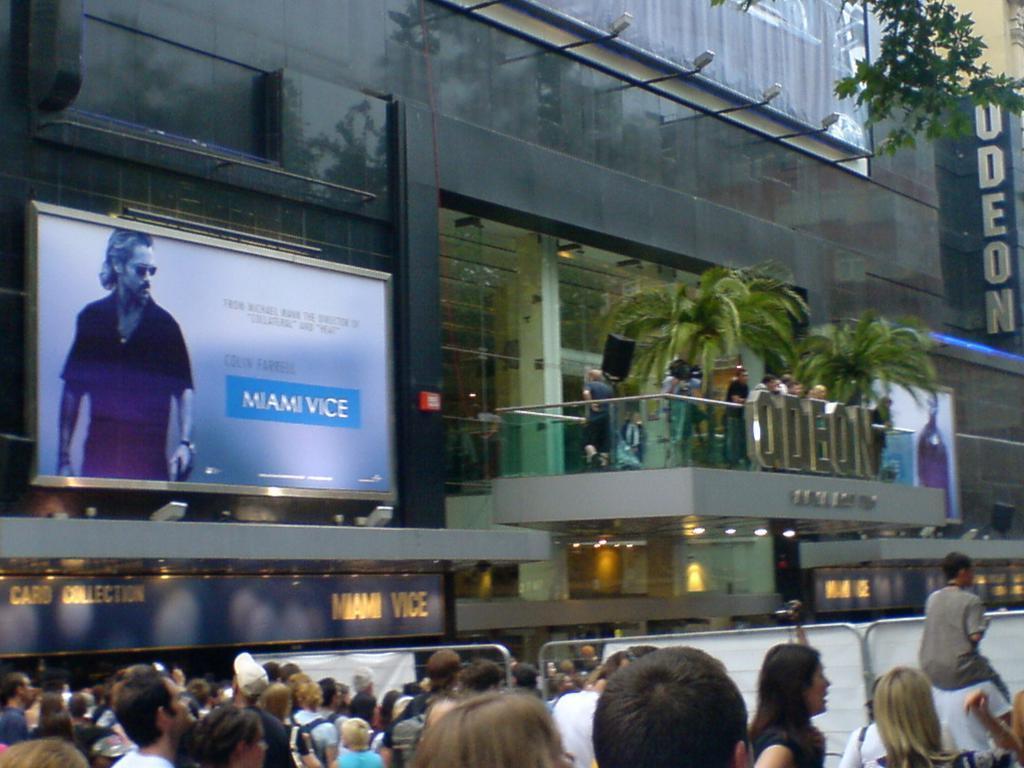Describe this image in one or two sentences. At the bottom of the picture, we see the people are standing. In front of them, we see the steel barriers and the banners in white color. On the left side, we see a hoarding board of a man. Beside that, we see the glass railing and the people are standing. In front of them, we see some text written on the glass railing. Behind them, we see the trees. On the right side, we see a board in blue color with some text written on it. Beside that, we see a tree. In the background, we see a building in black color. It has glass doors and windows. We even see the street lights. 